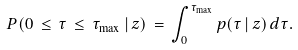<formula> <loc_0><loc_0><loc_500><loc_500>P ( 0 \, \leq \, \tau \, \leq \, \tau _ { \max } \, | \, z ) \, = \, \int _ { 0 } ^ { \tau _ { \max } } { p ( \tau \, | \, z ) \, d \tau } .</formula> 